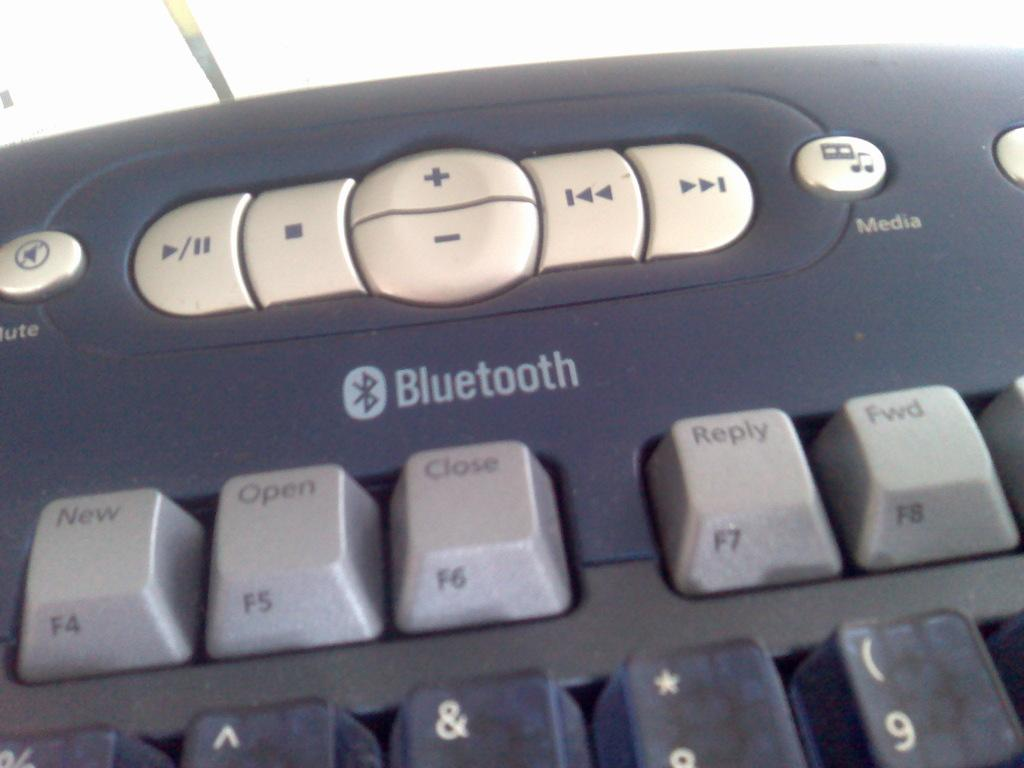<image>
Present a compact description of the photo's key features. A bluetooth keyboard is being used to type. 